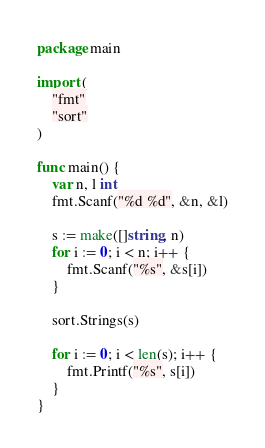<code> <loc_0><loc_0><loc_500><loc_500><_Go_>package main

import (
	"fmt"
	"sort"
)

func main() {
	var n, l int
	fmt.Scanf("%d %d", &n, &l)

	s := make([]string, n)
	for i := 0; i < n; i++ {
		fmt.Scanf("%s", &s[i])
	}

	sort.Strings(s)

	for i := 0; i < len(s); i++ {
		fmt.Printf("%s", s[i])
	}
}
</code> 